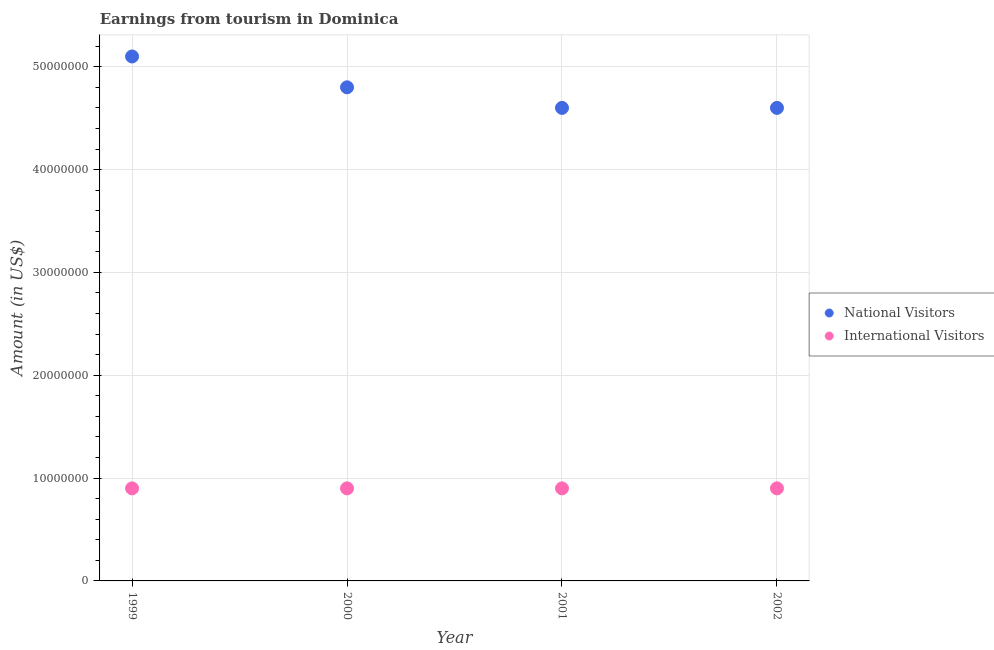How many different coloured dotlines are there?
Your answer should be compact. 2. Is the number of dotlines equal to the number of legend labels?
Ensure brevity in your answer.  Yes. What is the amount earned from international visitors in 2001?
Make the answer very short. 9.00e+06. Across all years, what is the maximum amount earned from international visitors?
Provide a short and direct response. 9.00e+06. Across all years, what is the minimum amount earned from international visitors?
Your answer should be compact. 9.00e+06. In which year was the amount earned from national visitors minimum?
Give a very brief answer. 2001. What is the total amount earned from international visitors in the graph?
Provide a succinct answer. 3.60e+07. What is the difference between the amount earned from international visitors in 1999 and the amount earned from national visitors in 2002?
Your answer should be compact. -3.70e+07. What is the average amount earned from national visitors per year?
Offer a terse response. 4.78e+07. In the year 2001, what is the difference between the amount earned from international visitors and amount earned from national visitors?
Your answer should be compact. -3.70e+07. In how many years, is the amount earned from international visitors greater than 40000000 US$?
Offer a terse response. 0. What is the ratio of the amount earned from international visitors in 1999 to that in 2002?
Your answer should be very brief. 1. Is the difference between the amount earned from international visitors in 2000 and 2002 greater than the difference between the amount earned from national visitors in 2000 and 2002?
Offer a very short reply. No. Is the sum of the amount earned from international visitors in 2000 and 2002 greater than the maximum amount earned from national visitors across all years?
Offer a very short reply. No. Does the amount earned from international visitors monotonically increase over the years?
Provide a short and direct response. No. Is the amount earned from international visitors strictly greater than the amount earned from national visitors over the years?
Ensure brevity in your answer.  No. Are the values on the major ticks of Y-axis written in scientific E-notation?
Your response must be concise. No. Where does the legend appear in the graph?
Ensure brevity in your answer.  Center right. How many legend labels are there?
Your response must be concise. 2. What is the title of the graph?
Your answer should be compact. Earnings from tourism in Dominica. Does "Pregnant women" appear as one of the legend labels in the graph?
Ensure brevity in your answer.  No. What is the label or title of the X-axis?
Your response must be concise. Year. What is the label or title of the Y-axis?
Ensure brevity in your answer.  Amount (in US$). What is the Amount (in US$) of National Visitors in 1999?
Provide a succinct answer. 5.10e+07. What is the Amount (in US$) of International Visitors in 1999?
Offer a terse response. 9.00e+06. What is the Amount (in US$) in National Visitors in 2000?
Keep it short and to the point. 4.80e+07. What is the Amount (in US$) of International Visitors in 2000?
Make the answer very short. 9.00e+06. What is the Amount (in US$) in National Visitors in 2001?
Make the answer very short. 4.60e+07. What is the Amount (in US$) of International Visitors in 2001?
Keep it short and to the point. 9.00e+06. What is the Amount (in US$) in National Visitors in 2002?
Your answer should be compact. 4.60e+07. What is the Amount (in US$) in International Visitors in 2002?
Your answer should be compact. 9.00e+06. Across all years, what is the maximum Amount (in US$) in National Visitors?
Your response must be concise. 5.10e+07. Across all years, what is the maximum Amount (in US$) of International Visitors?
Make the answer very short. 9.00e+06. Across all years, what is the minimum Amount (in US$) in National Visitors?
Make the answer very short. 4.60e+07. Across all years, what is the minimum Amount (in US$) in International Visitors?
Your answer should be compact. 9.00e+06. What is the total Amount (in US$) in National Visitors in the graph?
Your response must be concise. 1.91e+08. What is the total Amount (in US$) of International Visitors in the graph?
Ensure brevity in your answer.  3.60e+07. What is the difference between the Amount (in US$) in National Visitors in 1999 and that in 2000?
Your answer should be compact. 3.00e+06. What is the difference between the Amount (in US$) of International Visitors in 1999 and that in 2001?
Your answer should be very brief. 0. What is the difference between the Amount (in US$) in National Visitors in 1999 and that in 2002?
Your answer should be compact. 5.00e+06. What is the difference between the Amount (in US$) in International Visitors in 1999 and that in 2002?
Offer a very short reply. 0. What is the difference between the Amount (in US$) of National Visitors in 2000 and that in 2001?
Offer a very short reply. 2.00e+06. What is the difference between the Amount (in US$) of International Visitors in 2000 and that in 2001?
Give a very brief answer. 0. What is the difference between the Amount (in US$) in National Visitors in 2000 and that in 2002?
Provide a short and direct response. 2.00e+06. What is the difference between the Amount (in US$) of International Visitors in 2000 and that in 2002?
Your answer should be very brief. 0. What is the difference between the Amount (in US$) of International Visitors in 2001 and that in 2002?
Offer a terse response. 0. What is the difference between the Amount (in US$) of National Visitors in 1999 and the Amount (in US$) of International Visitors in 2000?
Your answer should be compact. 4.20e+07. What is the difference between the Amount (in US$) in National Visitors in 1999 and the Amount (in US$) in International Visitors in 2001?
Give a very brief answer. 4.20e+07. What is the difference between the Amount (in US$) in National Visitors in 1999 and the Amount (in US$) in International Visitors in 2002?
Ensure brevity in your answer.  4.20e+07. What is the difference between the Amount (in US$) of National Visitors in 2000 and the Amount (in US$) of International Visitors in 2001?
Offer a very short reply. 3.90e+07. What is the difference between the Amount (in US$) in National Visitors in 2000 and the Amount (in US$) in International Visitors in 2002?
Give a very brief answer. 3.90e+07. What is the difference between the Amount (in US$) of National Visitors in 2001 and the Amount (in US$) of International Visitors in 2002?
Offer a very short reply. 3.70e+07. What is the average Amount (in US$) in National Visitors per year?
Keep it short and to the point. 4.78e+07. What is the average Amount (in US$) in International Visitors per year?
Your response must be concise. 9.00e+06. In the year 1999, what is the difference between the Amount (in US$) of National Visitors and Amount (in US$) of International Visitors?
Provide a succinct answer. 4.20e+07. In the year 2000, what is the difference between the Amount (in US$) in National Visitors and Amount (in US$) in International Visitors?
Ensure brevity in your answer.  3.90e+07. In the year 2001, what is the difference between the Amount (in US$) of National Visitors and Amount (in US$) of International Visitors?
Make the answer very short. 3.70e+07. In the year 2002, what is the difference between the Amount (in US$) in National Visitors and Amount (in US$) in International Visitors?
Make the answer very short. 3.70e+07. What is the ratio of the Amount (in US$) in National Visitors in 1999 to that in 2000?
Provide a succinct answer. 1.06. What is the ratio of the Amount (in US$) in International Visitors in 1999 to that in 2000?
Your answer should be very brief. 1. What is the ratio of the Amount (in US$) of National Visitors in 1999 to that in 2001?
Offer a very short reply. 1.11. What is the ratio of the Amount (in US$) of National Visitors in 1999 to that in 2002?
Provide a succinct answer. 1.11. What is the ratio of the Amount (in US$) in International Visitors in 1999 to that in 2002?
Your answer should be compact. 1. What is the ratio of the Amount (in US$) in National Visitors in 2000 to that in 2001?
Offer a very short reply. 1.04. What is the ratio of the Amount (in US$) of National Visitors in 2000 to that in 2002?
Your answer should be compact. 1.04. What is the ratio of the Amount (in US$) of International Visitors in 2000 to that in 2002?
Ensure brevity in your answer.  1. What is the difference between the highest and the second highest Amount (in US$) in National Visitors?
Offer a very short reply. 3.00e+06. What is the difference between the highest and the second highest Amount (in US$) of International Visitors?
Offer a terse response. 0. What is the difference between the highest and the lowest Amount (in US$) in International Visitors?
Offer a terse response. 0. 